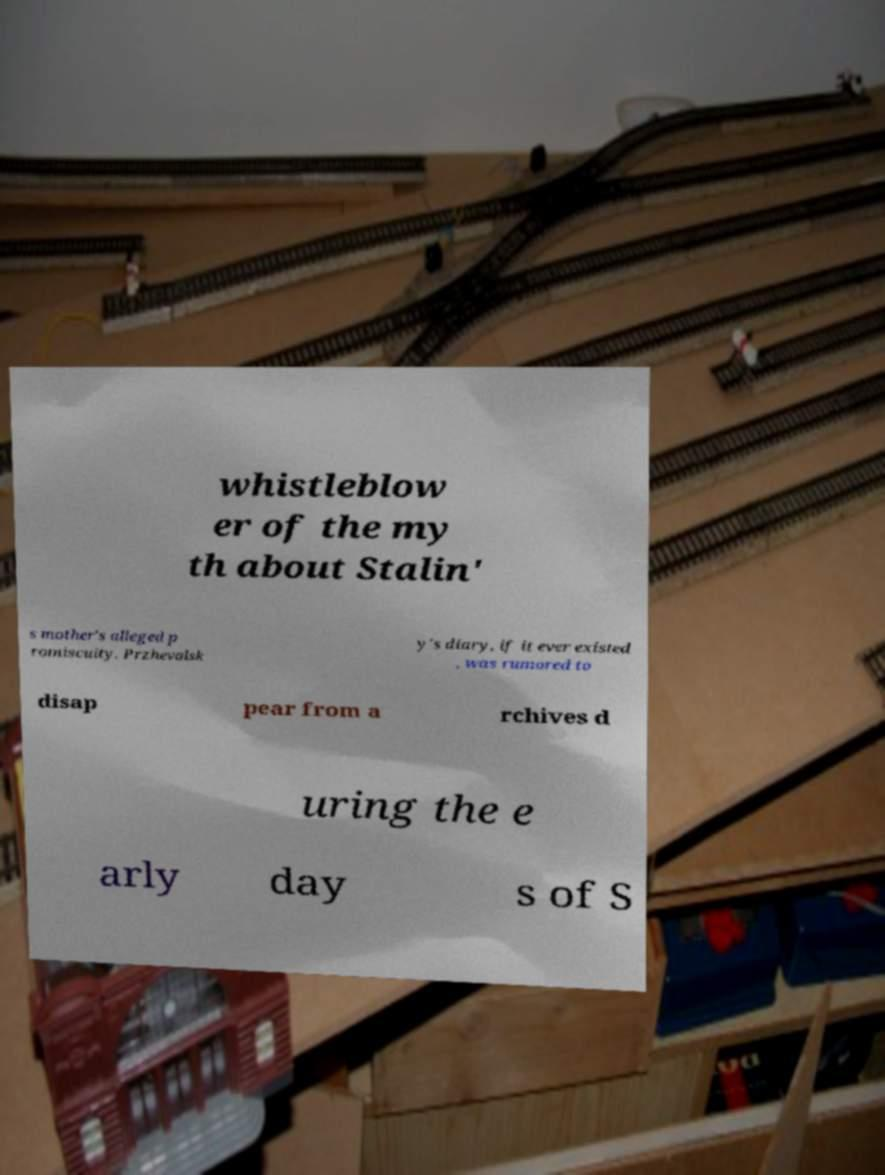Can you accurately transcribe the text from the provided image for me? whistleblow er of the my th about Stalin' s mother's alleged p romiscuity. Przhevalsk y's diary, if it ever existed , was rumored to disap pear from a rchives d uring the e arly day s of S 